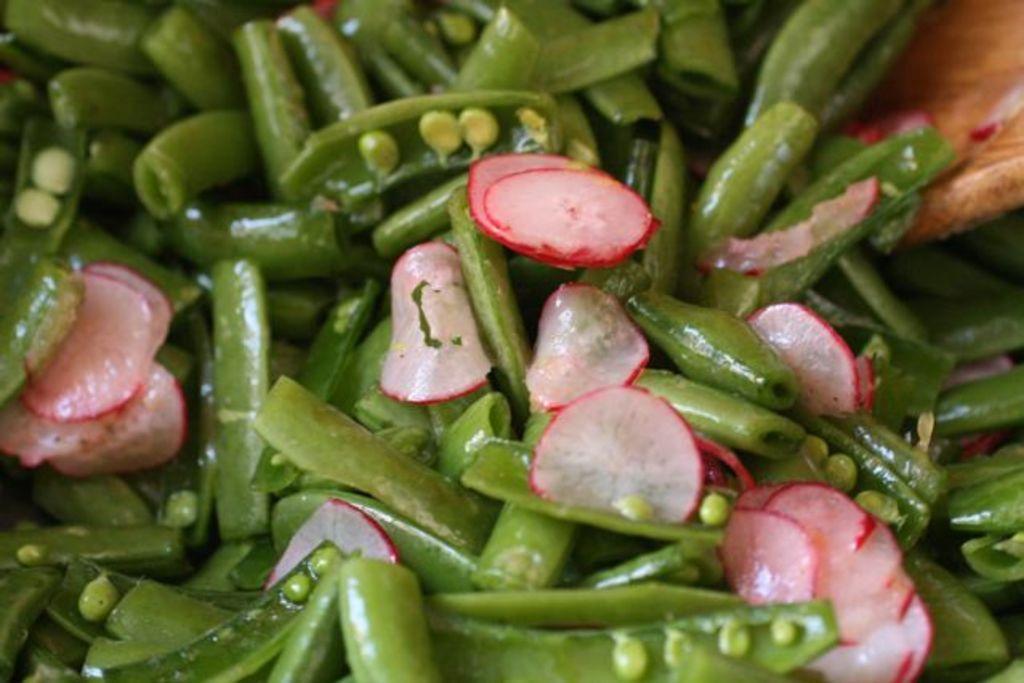How would you summarize this image in a sentence or two? In this picture we can see sliced radish and green beans. In the top right corner of the image, there is a wooden object. 